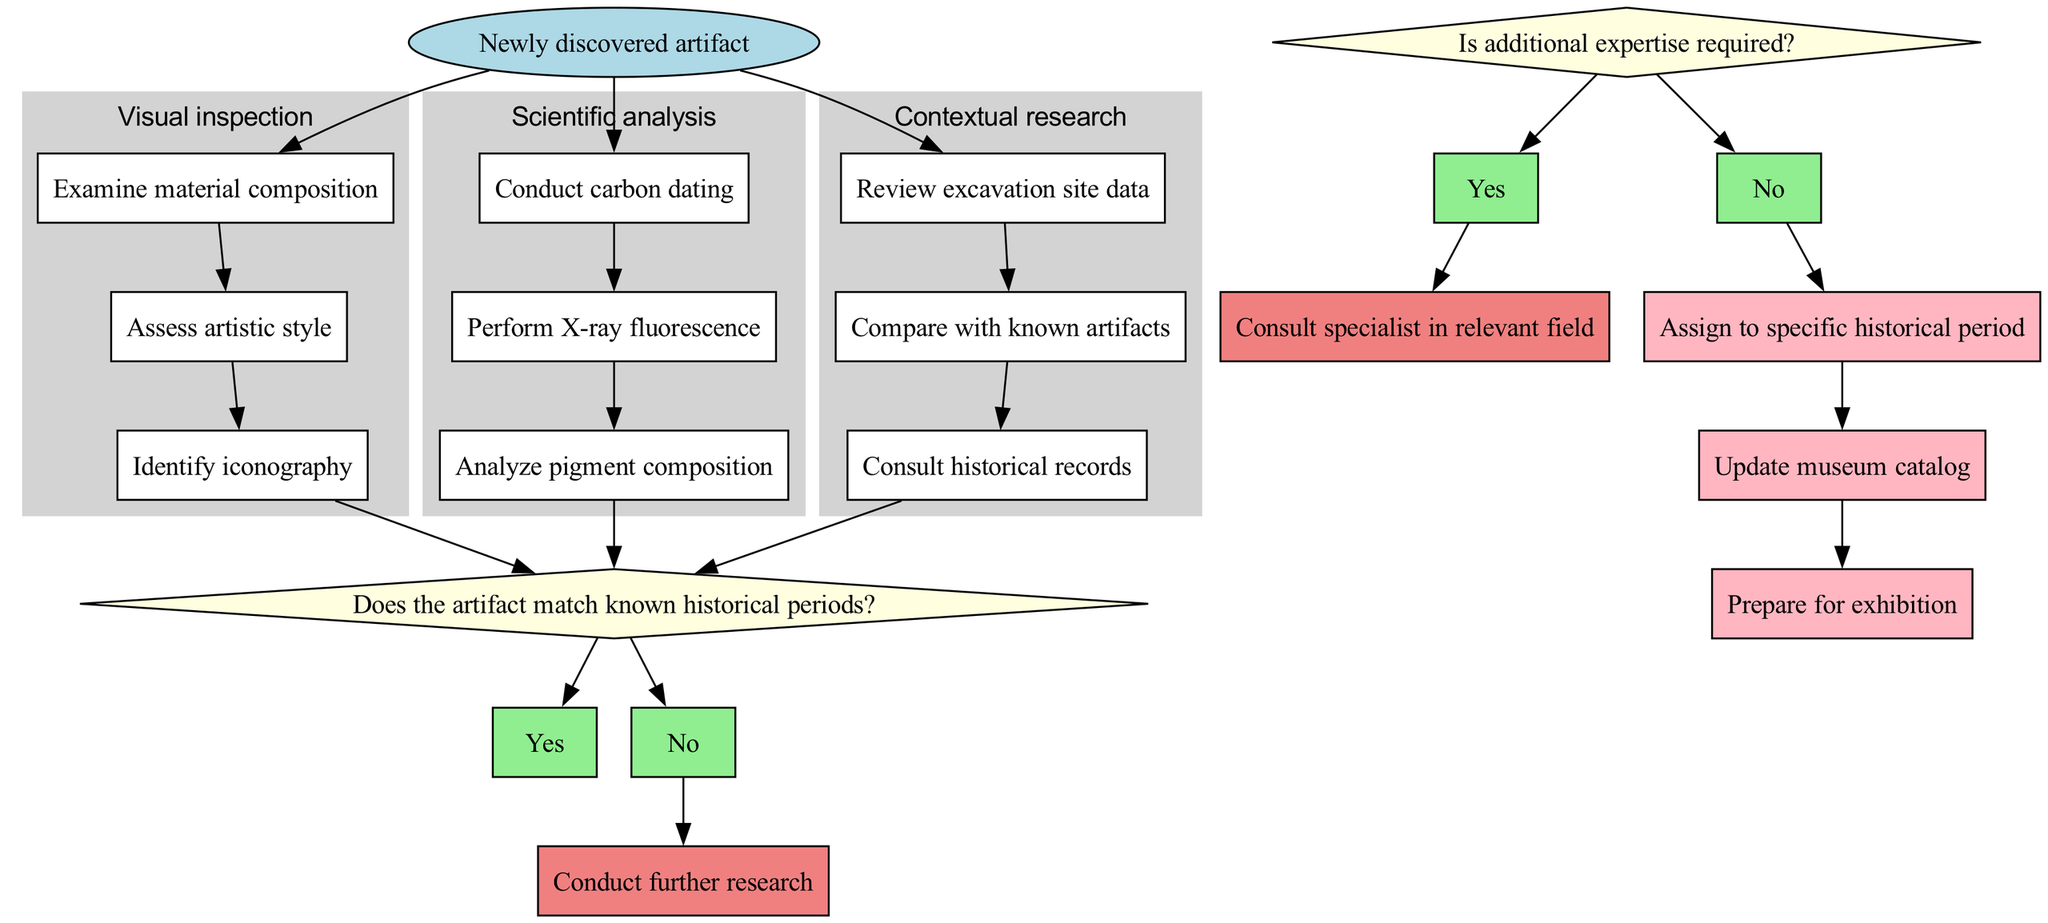What is the starting point of the diagram? The diagram starts with the node labeled "Newly discovered artifact", indicating the beginning of the diagnostic pathway for newly discovered artifacts.
Answer: Newly discovered artifact How many processes are there in the diagram? There are three processes listed in the diagram: Visual inspection, Scientific analysis, and Contextual research.
Answer: 3 What is the first step in the "Scientific analysis" process? The first step in the "Scientific analysis" process is labeled "Conduct carbon dating", where the process begins by determining the age of the artifact through carbon dating techniques.
Answer: Conduct carbon dating What question is posed at the first decision point? The first decision point asks, "Does the artifact match known historical periods?", which is crucial for determining whether further research is needed.
Answer: Does the artifact match known historical periods? If the answer to the first decision point is "No", what action follows? If the answer is "No," the follow-up action is to "Conduct further research", indicating that additional investigation is necessary to properly categorize the artifact.
Answer: Conduct further research Which process includes the step "Analyze pigment composition"? The step "Analyze pigment composition" is included in the "Scientific analysis" process, signifying the examination of the artifact's paint or color elements.
Answer: Scientific analysis What happens after the "Contextual research" process? After completing the "Contextual research" process, the flow leads to the first decision point, where the question about matching historical periods is asked, indicating that the results should be evaluated.
Answer: Decision point How many end nodes are there, and what are they? There are three end nodes: "Assign to specific historical period", "Update museum catalog", and "Prepare for exhibition", which represent the final steps after completing the diagnostic pathway.
Answer: 3 What happens if additional expertise is required? If the answer to whether additional expertise is required is "Yes", the follow-up action is to "Consult specialist in relevant field." This emphasizes the need for expert guidance in some cases.
Answer: Consult specialist in relevant field 